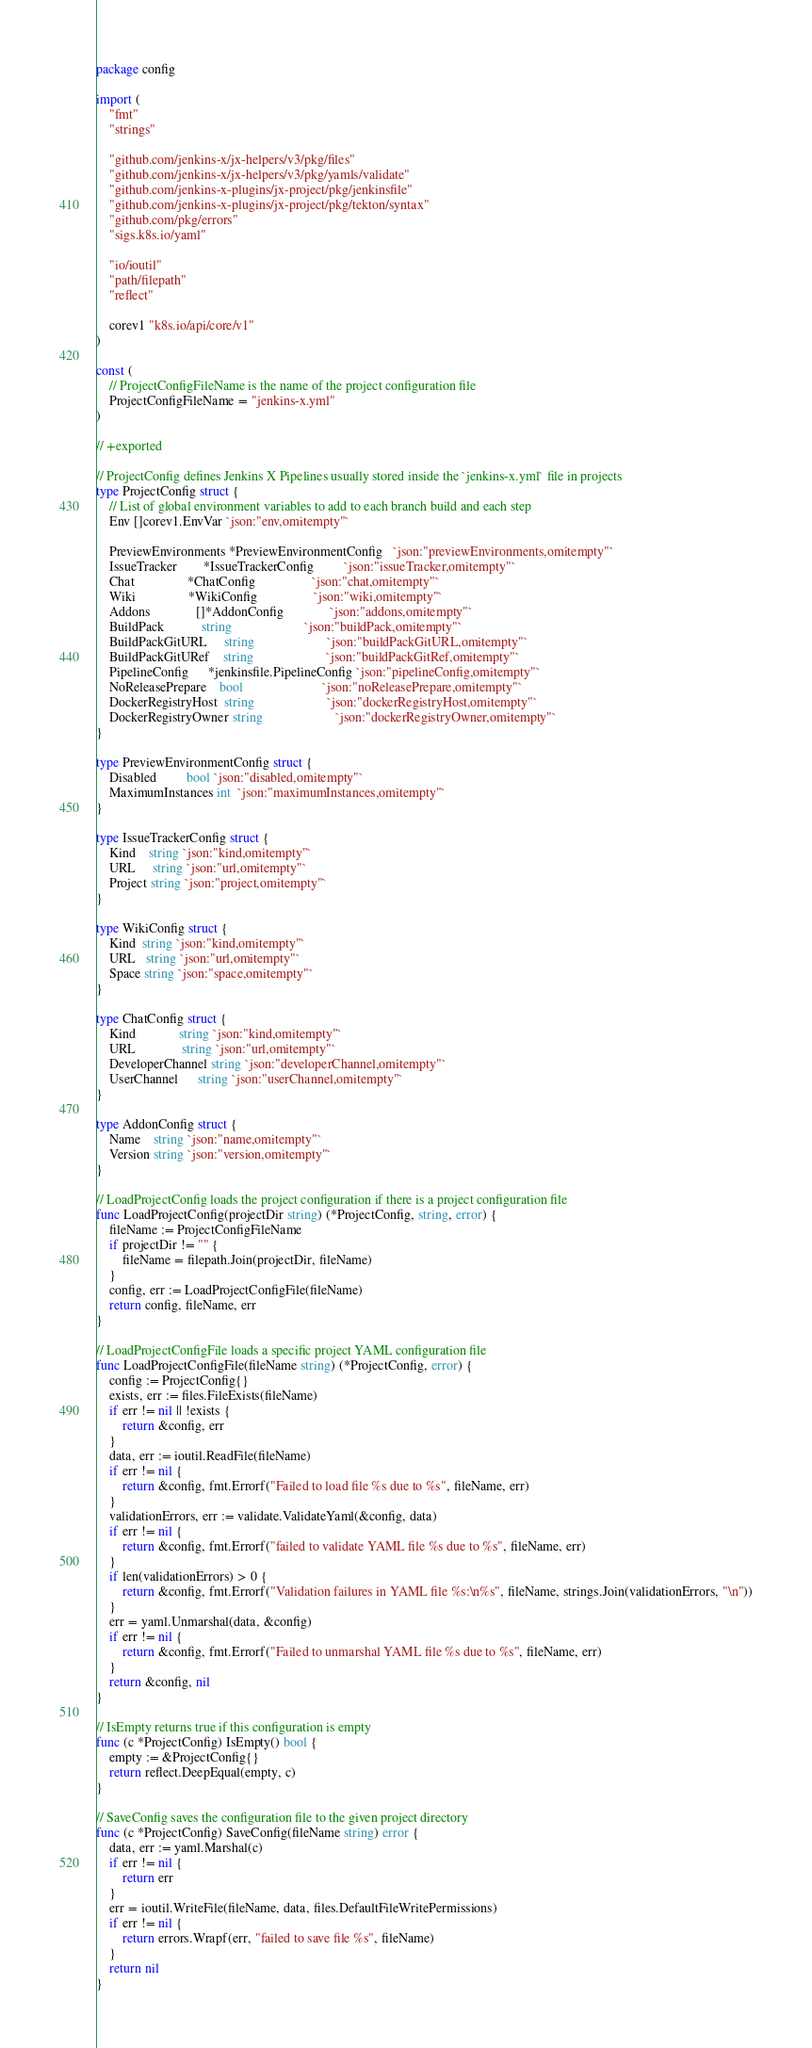<code> <loc_0><loc_0><loc_500><loc_500><_Go_>package config

import (
	"fmt"
	"strings"

	"github.com/jenkins-x/jx-helpers/v3/pkg/files"
	"github.com/jenkins-x/jx-helpers/v3/pkg/yamls/validate"
	"github.com/jenkins-x-plugins/jx-project/pkg/jenkinsfile"
	"github.com/jenkins-x-plugins/jx-project/pkg/tekton/syntax"
	"github.com/pkg/errors"
	"sigs.k8s.io/yaml"

	"io/ioutil"
	"path/filepath"
	"reflect"

	corev1 "k8s.io/api/core/v1"
)

const (
	// ProjectConfigFileName is the name of the project configuration file
	ProjectConfigFileName = "jenkins-x.yml"
)

// +exported

// ProjectConfig defines Jenkins X Pipelines usually stored inside the `jenkins-x.yml` file in projects
type ProjectConfig struct {
	// List of global environment variables to add to each branch build and each step
	Env []corev1.EnvVar `json:"env,omitempty"`

	PreviewEnvironments *PreviewEnvironmentConfig   `json:"previewEnvironments,omitempty"`
	IssueTracker        *IssueTrackerConfig         `json:"issueTracker,omitempty"`
	Chat                *ChatConfig                 `json:"chat,omitempty"`
	Wiki                *WikiConfig                 `json:"wiki,omitempty"`
	Addons              []*AddonConfig              `json:"addons,omitempty"`
	BuildPack           string                      `json:"buildPack,omitempty"`
	BuildPackGitURL     string                      `json:"buildPackGitURL,omitempty"`
	BuildPackGitURef    string                      `json:"buildPackGitRef,omitempty"`
	PipelineConfig      *jenkinsfile.PipelineConfig `json:"pipelineConfig,omitempty"`
	NoReleasePrepare    bool                        `json:"noReleasePrepare,omitempty"`
	DockerRegistryHost  string                      `json:"dockerRegistryHost,omitempty"`
	DockerRegistryOwner string                      `json:"dockerRegistryOwner,omitempty"`
}

type PreviewEnvironmentConfig struct {
	Disabled         bool `json:"disabled,omitempty"`
	MaximumInstances int  `json:"maximumInstances,omitempty"`
}

type IssueTrackerConfig struct {
	Kind    string `json:"kind,omitempty"`
	URL     string `json:"url,omitempty"`
	Project string `json:"project,omitempty"`
}

type WikiConfig struct {
	Kind  string `json:"kind,omitempty"`
	URL   string `json:"url,omitempty"`
	Space string `json:"space,omitempty"`
}

type ChatConfig struct {
	Kind             string `json:"kind,omitempty"`
	URL              string `json:"url,omitempty"`
	DeveloperChannel string `json:"developerChannel,omitempty"`
	UserChannel      string `json:"userChannel,omitempty"`
}

type AddonConfig struct {
	Name    string `json:"name,omitempty"`
	Version string `json:"version,omitempty"`
}

// LoadProjectConfig loads the project configuration if there is a project configuration file
func LoadProjectConfig(projectDir string) (*ProjectConfig, string, error) {
	fileName := ProjectConfigFileName
	if projectDir != "" {
		fileName = filepath.Join(projectDir, fileName)
	}
	config, err := LoadProjectConfigFile(fileName)
	return config, fileName, err
}

// LoadProjectConfigFile loads a specific project YAML configuration file
func LoadProjectConfigFile(fileName string) (*ProjectConfig, error) {
	config := ProjectConfig{}
	exists, err := files.FileExists(fileName)
	if err != nil || !exists {
		return &config, err
	}
	data, err := ioutil.ReadFile(fileName)
	if err != nil {
		return &config, fmt.Errorf("Failed to load file %s due to %s", fileName, err)
	}
	validationErrors, err := validate.ValidateYaml(&config, data)
	if err != nil {
		return &config, fmt.Errorf("failed to validate YAML file %s due to %s", fileName, err)
	}
	if len(validationErrors) > 0 {
		return &config, fmt.Errorf("Validation failures in YAML file %s:\n%s", fileName, strings.Join(validationErrors, "\n"))
	}
	err = yaml.Unmarshal(data, &config)
	if err != nil {
		return &config, fmt.Errorf("Failed to unmarshal YAML file %s due to %s", fileName, err)
	}
	return &config, nil
}

// IsEmpty returns true if this configuration is empty
func (c *ProjectConfig) IsEmpty() bool {
	empty := &ProjectConfig{}
	return reflect.DeepEqual(empty, c)
}

// SaveConfig saves the configuration file to the given project directory
func (c *ProjectConfig) SaveConfig(fileName string) error {
	data, err := yaml.Marshal(c)
	if err != nil {
		return err
	}
	err = ioutil.WriteFile(fileName, data, files.DefaultFileWritePermissions)
	if err != nil {
		return errors.Wrapf(err, "failed to save file %s", fileName)
	}
	return nil
}
</code> 